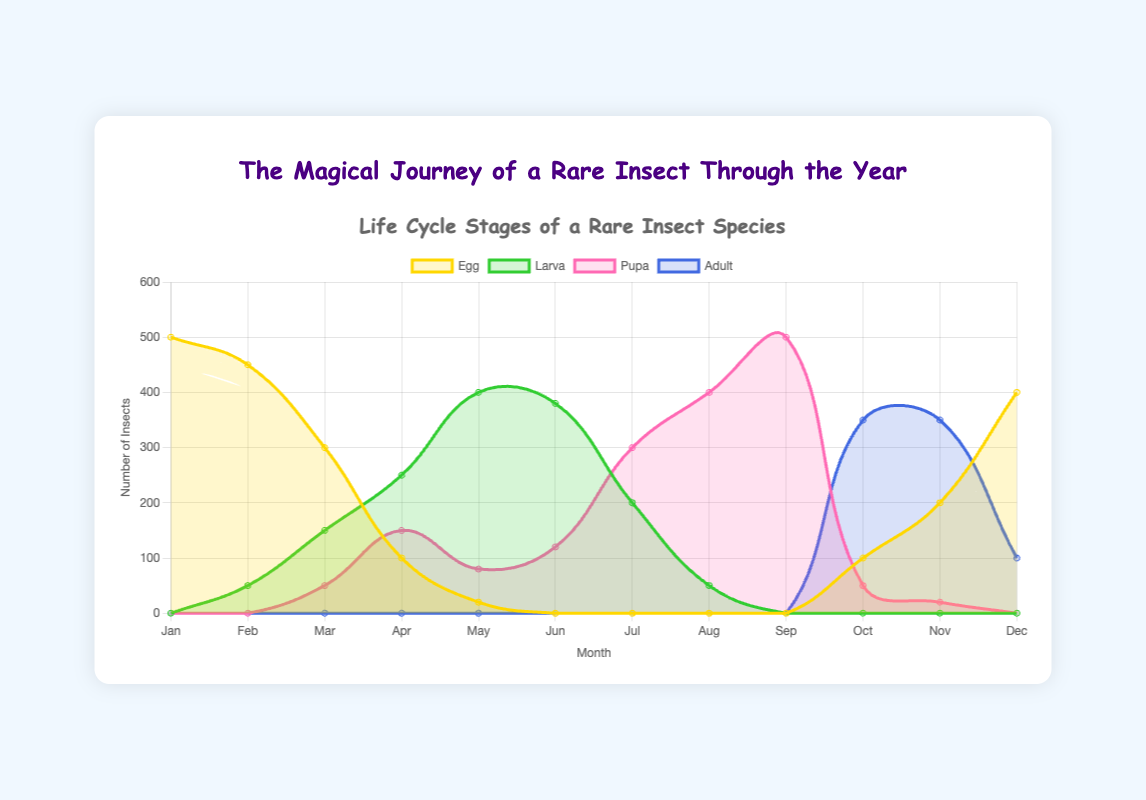What life cycle stage has the highest number of insects in January? In January, the 'Egg' stage has the highest number of insects with 500, as indicated by the height of the yellow curve for that month.
Answer: Egg During which month is the Larva stage at its peak? By observing the green curve, the Larva stage is at its highest in May with 400 insects.
Answer: May Is there any overlap between the Pupa and Adult stages' presence across the months? The Adult stage begins in October and overlaps with the Pupa stage from October to November, based on the visual presence of the pink and blue curves for those months.
Answer: Yes What is the total number of insects in the Larva and Pupa stages in April? April shows 250 insects in the Larva stage and 150 in the Pupa stage. Totaling these gives 250 + 150 = 400 insects.
Answer: 400 Which month has the greatest decrease in the number of eggs? From January to February, the number of eggs drops from 500 to 450, which is a decrease of 50. Further drops occur, but the largest is from February to March where eggs decrease from 450 to 300, a decrease of 150.
Answer: March Compare the number of insects in the Pupa stage in June and July. Which month has more? In June, the number is 120, while in July, it increases to 300. Thus, July has more insects in the Pupa stage.
Answer: July What trend do you observe in the Adult stage from October to December? The number of adults starts at 350 in October, remains 350 in November, and decreases to 100 in December. This indicates a downward trend in the Adult stage population.
Answer: Downward What is the difference in the number of eggs between December and January? December has 400 eggs while January has 500. The difference is 500 - 400 = 100 eggs.
Answer: 100 During which two consecutive months does the Pupa stage show the most significant increase? The Pupa stage sees the most significant increase from July to August, rising from 300 to 400, an increase of 100 insects.
Answer: July-August 